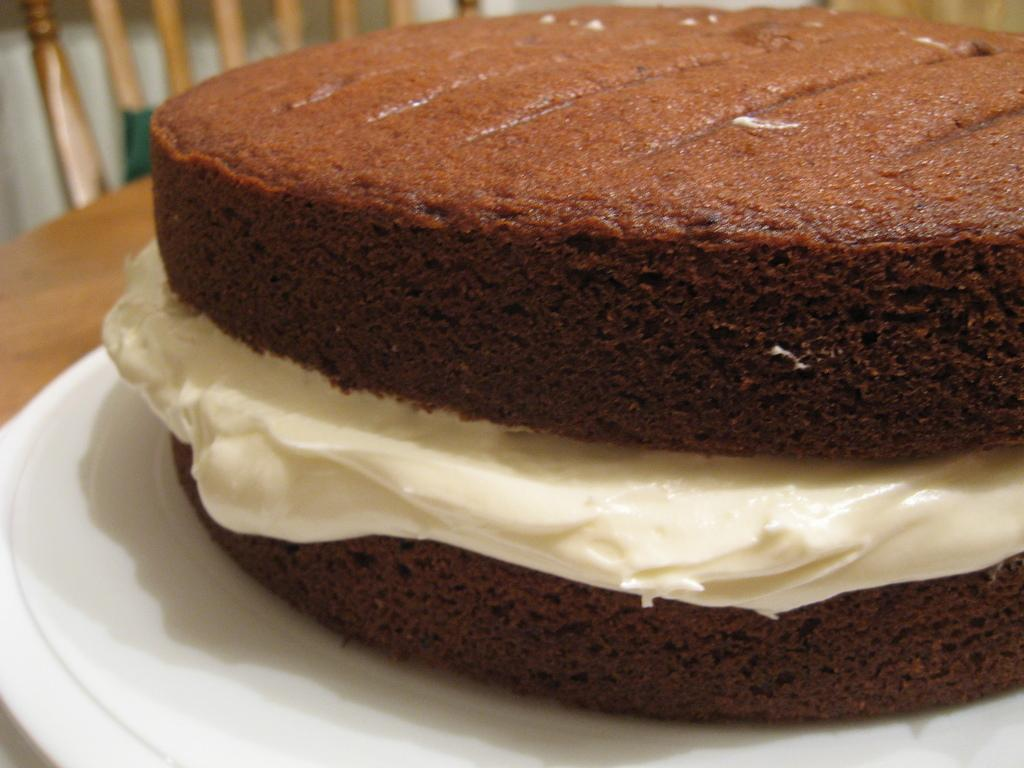What type of dessert is on the plate in the image? There is a chocolate cake on a plate in the image. Where is the plate with the cake located? The plate is on a table. Can you describe any furniture visible in the image? There appears to be a wooden chair in the top left side of the image. What grade does the chocolate cake receive for its presentation in the image? There is no grading system or evaluation present in the image, so it is not possible to assign a grade to the cake's presentation. 